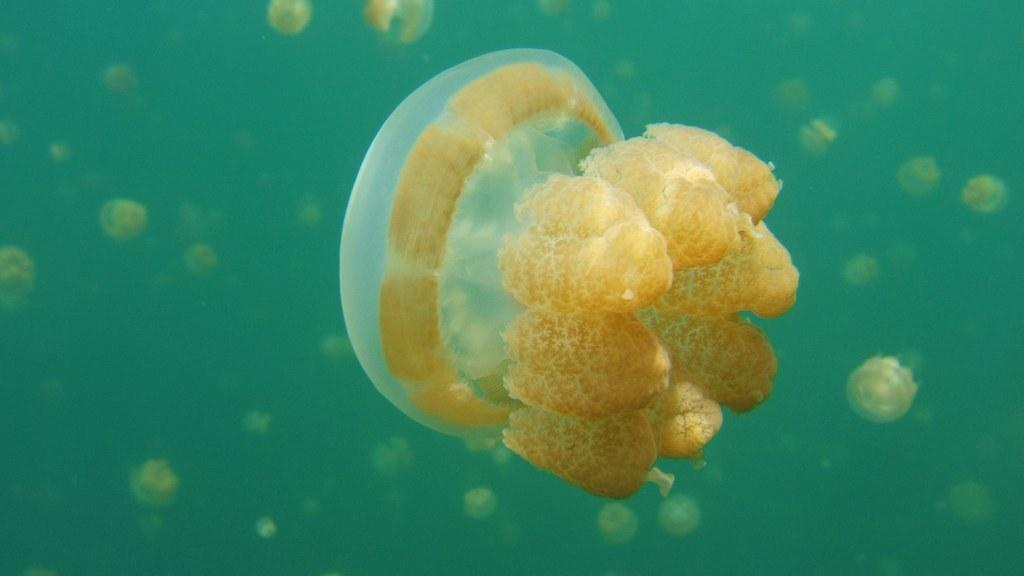What type of animals can be seen in the water in the image? There are jellyfishes in the water. Can you describe the environment in which the jellyfishes are located? The jellyfishes are located in the water. How many bananas are arranged in the image? There are no bananas present in the image; it features jellyfishes in the water. What type of coil can be seen in the image? There is no coil present in the image; it features jellyfishes in the water. 